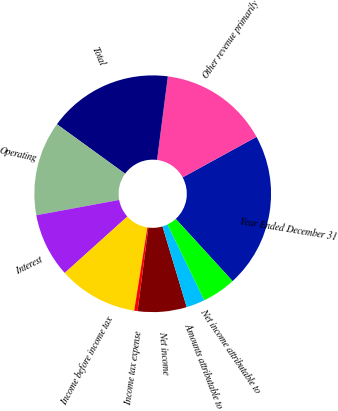<chart> <loc_0><loc_0><loc_500><loc_500><pie_chart><fcel>Year Ended December 31<fcel>Other revenue primarily<fcel>Total<fcel>Operating<fcel>Interest<fcel>Income before income tax<fcel>Income tax expense<fcel>Net income<fcel>Amounts attributable to<fcel>Net income attributable to<nl><fcel>21.19%<fcel>14.98%<fcel>17.05%<fcel>12.9%<fcel>8.76%<fcel>10.83%<fcel>0.46%<fcel>6.68%<fcel>2.54%<fcel>4.61%<nl></chart> 